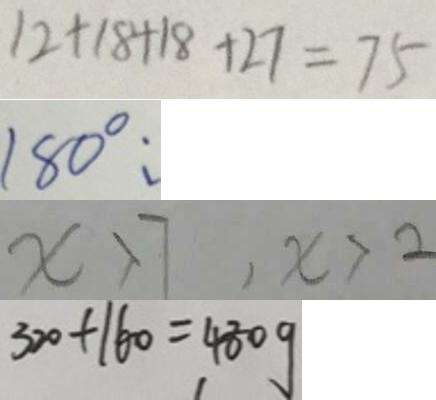<formula> <loc_0><loc_0><loc_500><loc_500>1 2 + 1 8 + 1 8 + 2 7 = 7 5 
 1 8 0 ^ { \circ } : 
 x > 7 , x > 2 
 3 2 0 + 1 6 0 = 4 8 0 g</formula> 